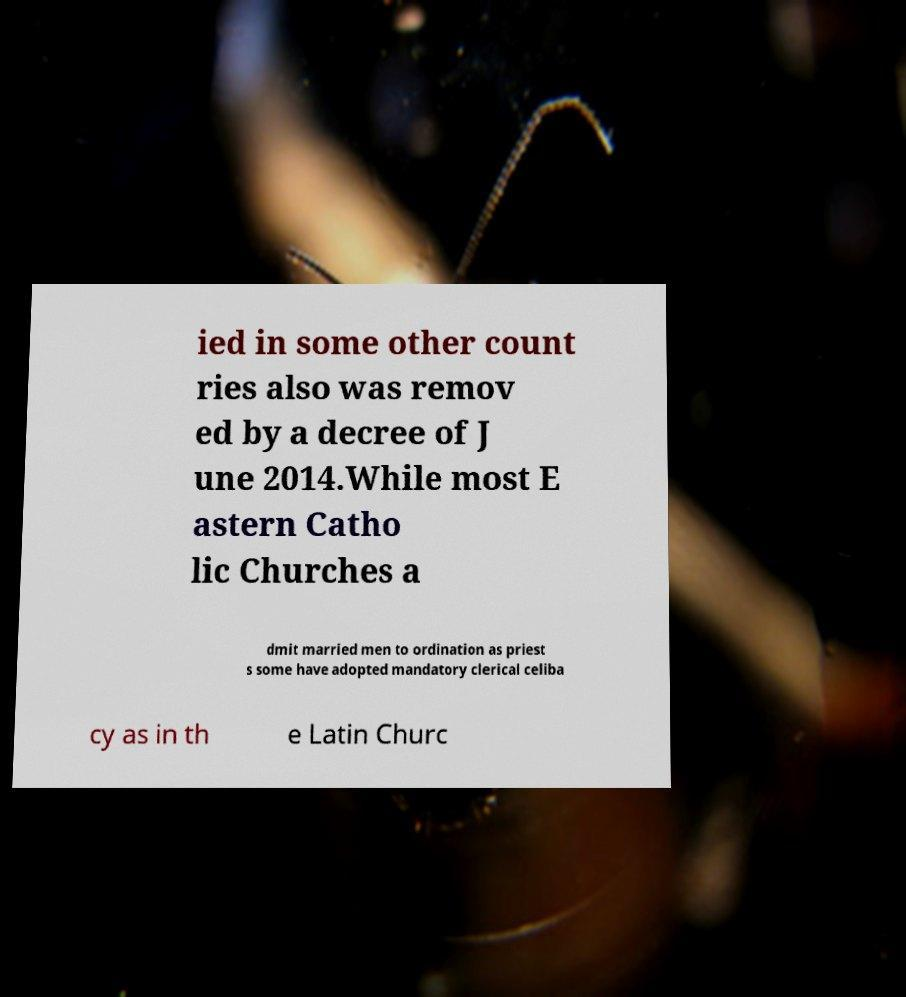Could you extract and type out the text from this image? ied in some other count ries also was remov ed by a decree of J une 2014.While most E astern Catho lic Churches a dmit married men to ordination as priest s some have adopted mandatory clerical celiba cy as in th e Latin Churc 